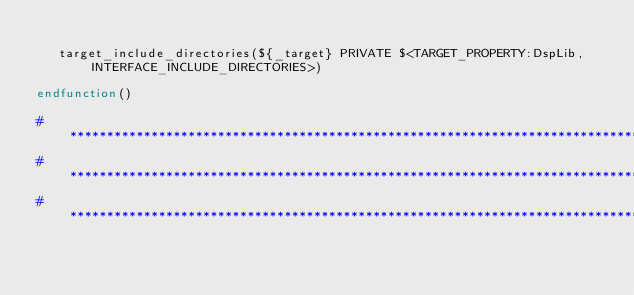Convert code to text. <code><loc_0><loc_0><loc_500><loc_500><_CMake_>
   target_include_directories(${_target} PRIVATE $<TARGET_PROPERTY:DspLib,INTERFACE_INCLUDE_DIRECTORIES>)

endfunction()

#*******************************************************************************
#*******************************************************************************
#*******************************************************************************

</code> 